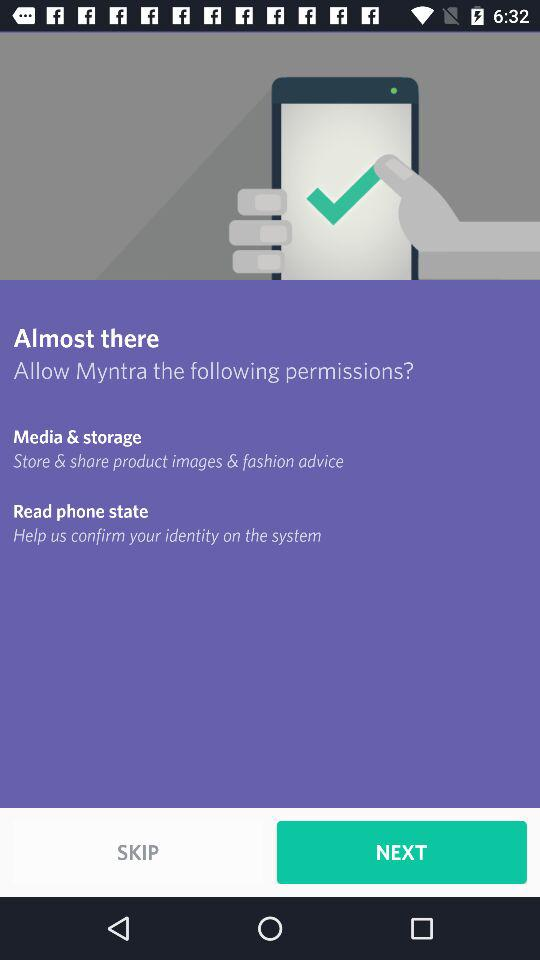How many permissions are being requested?
Answer the question using a single word or phrase. 2 